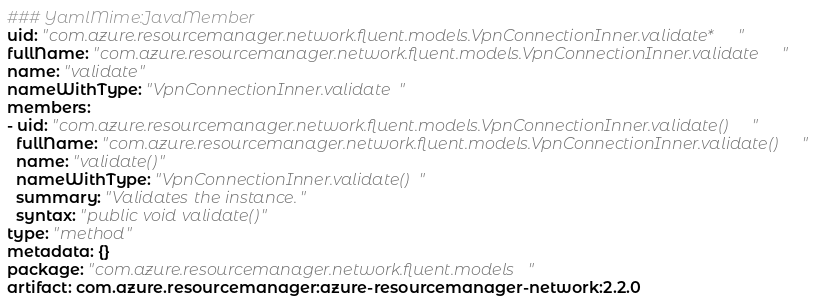Convert code to text. <code><loc_0><loc_0><loc_500><loc_500><_YAML_>### YamlMime:JavaMember
uid: "com.azure.resourcemanager.network.fluent.models.VpnConnectionInner.validate*"
fullName: "com.azure.resourcemanager.network.fluent.models.VpnConnectionInner.validate"
name: "validate"
nameWithType: "VpnConnectionInner.validate"
members:
- uid: "com.azure.resourcemanager.network.fluent.models.VpnConnectionInner.validate()"
  fullName: "com.azure.resourcemanager.network.fluent.models.VpnConnectionInner.validate()"
  name: "validate()"
  nameWithType: "VpnConnectionInner.validate()"
  summary: "Validates the instance."
  syntax: "public void validate()"
type: "method"
metadata: {}
package: "com.azure.resourcemanager.network.fluent.models"
artifact: com.azure.resourcemanager:azure-resourcemanager-network:2.2.0
</code> 